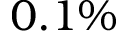<formula> <loc_0><loc_0><loc_500><loc_500>0 . 1 \%</formula> 